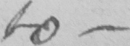Can you tell me what this handwritten text says? to  _ 